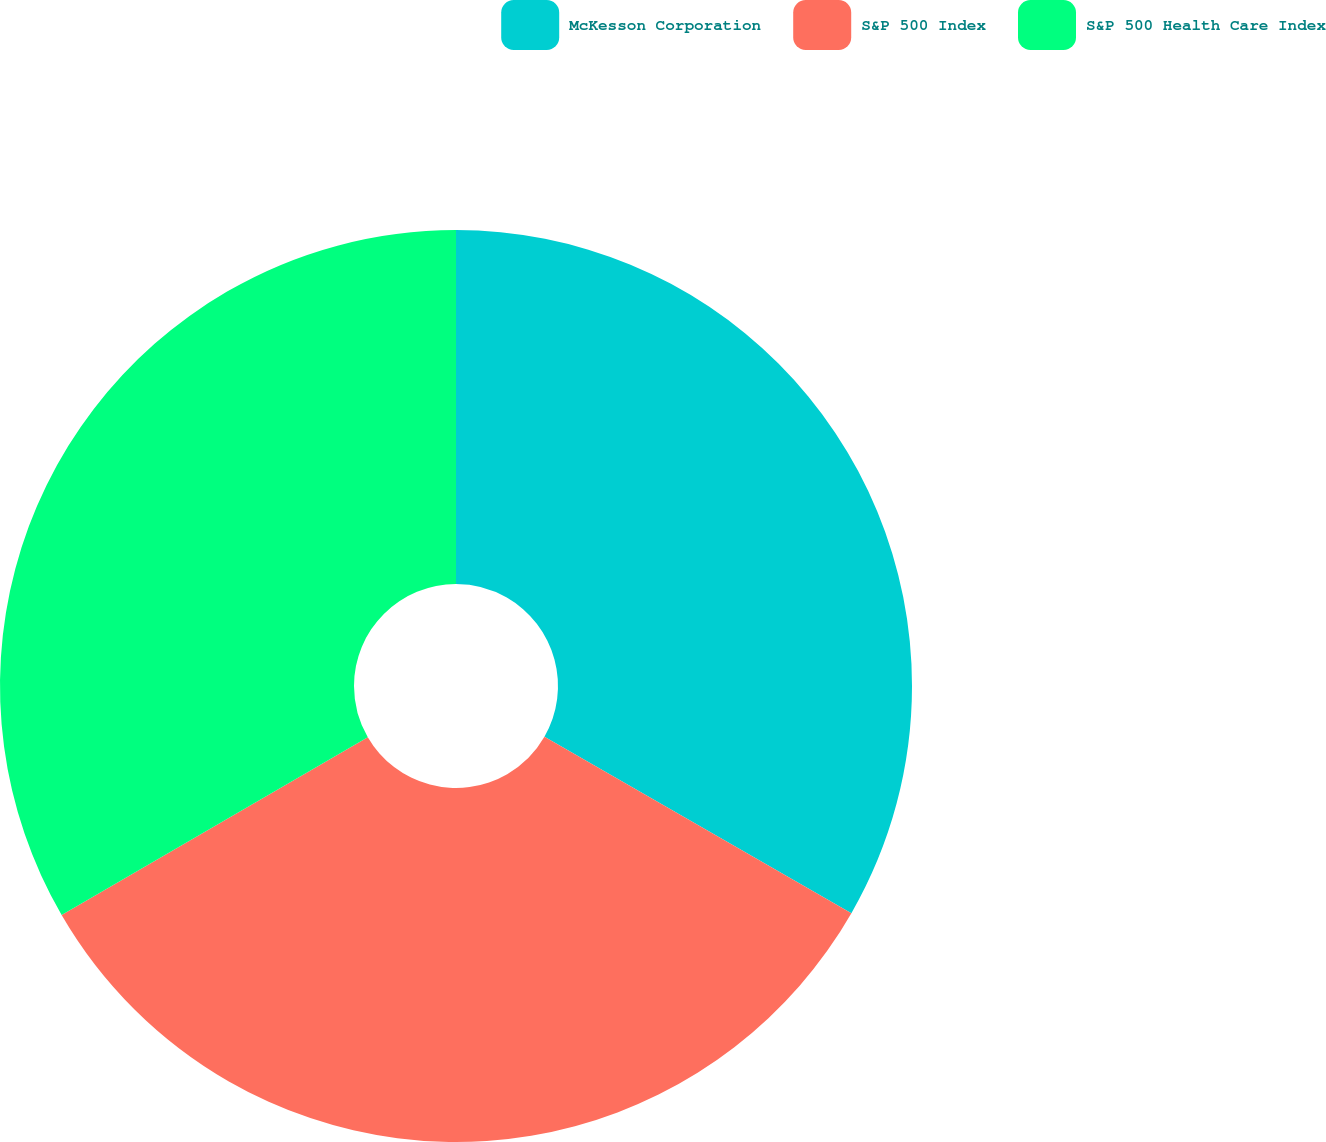Convert chart. <chart><loc_0><loc_0><loc_500><loc_500><pie_chart><fcel>McKesson Corporation<fcel>S&P 500 Index<fcel>S&P 500 Health Care Index<nl><fcel>33.3%<fcel>33.33%<fcel>33.37%<nl></chart> 